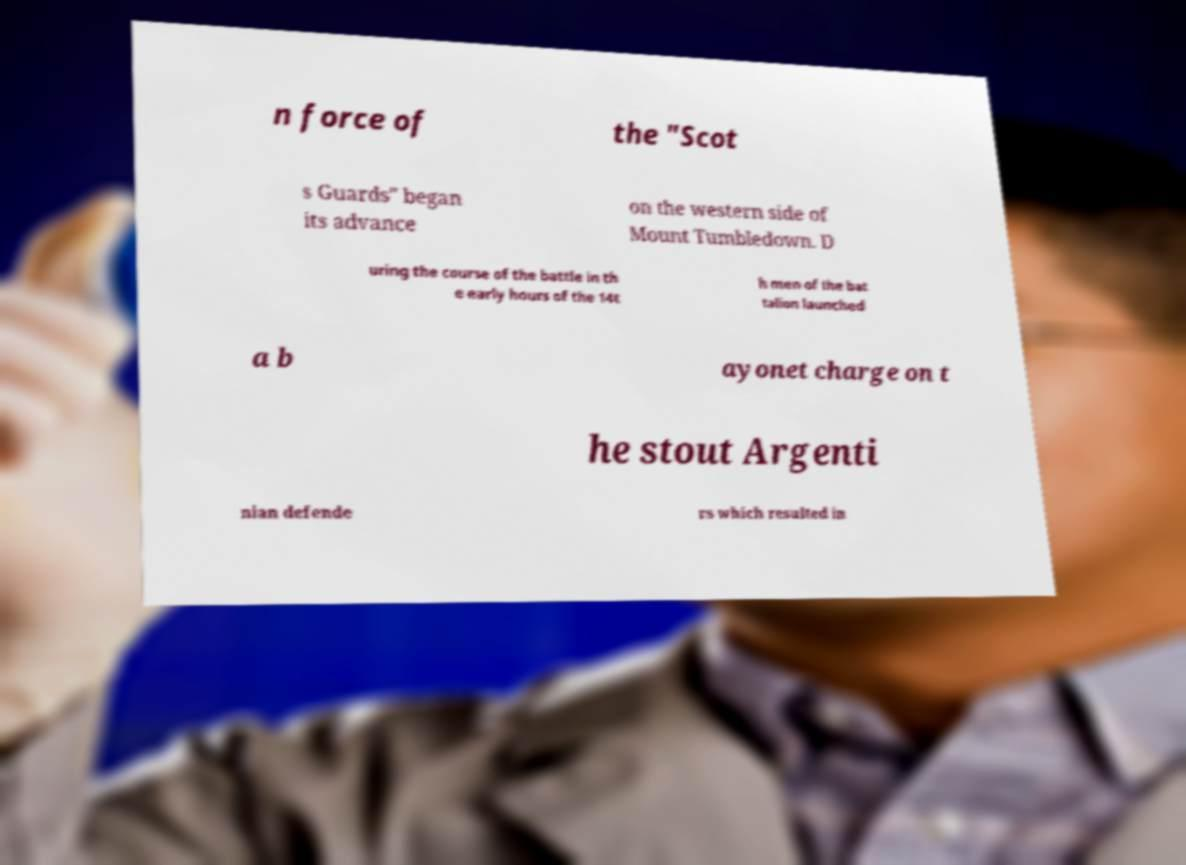Please read and relay the text visible in this image. What does it say? n force of the "Scot s Guards" began its advance on the western side of Mount Tumbledown. D uring the course of the battle in th e early hours of the 14t h men of the bat talion launched a b ayonet charge on t he stout Argenti nian defende rs which resulted in 